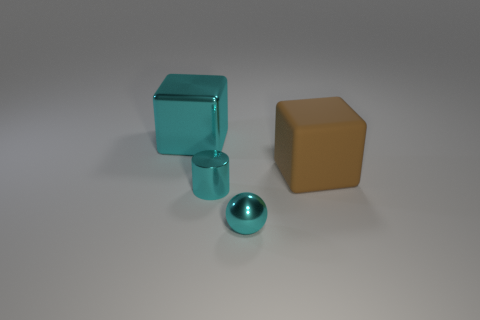Add 4 shiny spheres. How many objects exist? 8 Subtract all balls. How many objects are left? 3 Subtract 0 red cubes. How many objects are left? 4 Subtract all cubes. Subtract all tiny cyan objects. How many objects are left? 0 Add 4 small shiny things. How many small shiny things are left? 6 Add 3 shiny objects. How many shiny objects exist? 6 